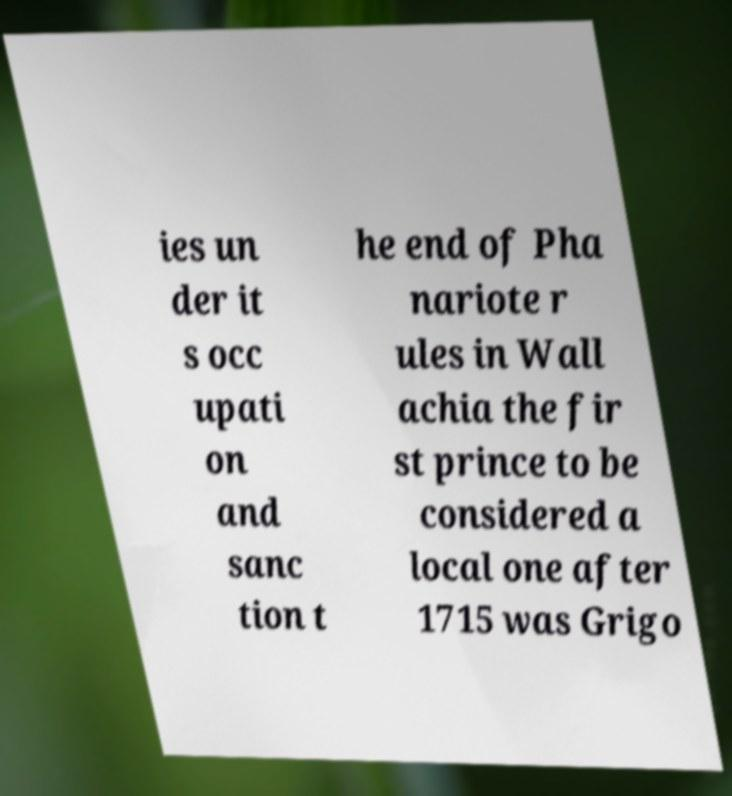There's text embedded in this image that I need extracted. Can you transcribe it verbatim? ies un der it s occ upati on and sanc tion t he end of Pha nariote r ules in Wall achia the fir st prince to be considered a local one after 1715 was Grigo 